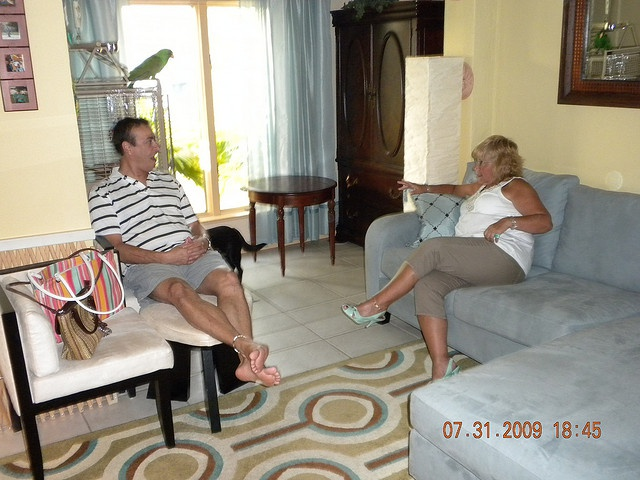Describe the objects in this image and their specific colors. I can see couch in gray, darkgray, and lightgray tones, people in gray, lightgray, and darkgray tones, people in gray, lightgray, and maroon tones, chair in gray, lightgray, black, and darkgray tones, and chair in gray, black, darkgray, and tan tones in this image. 